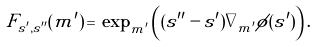Convert formula to latex. <formula><loc_0><loc_0><loc_500><loc_500>F _ { s ^ { \prime } , s ^ { \prime \prime } } ( m ^ { \prime } ) \, = \, \exp _ { m ^ { \prime } } \left ( ( s ^ { \prime \prime } - s ^ { \prime } ) \nabla _ { m ^ { \prime } } \phi ( s ^ { \prime } ) \right ) .</formula> 